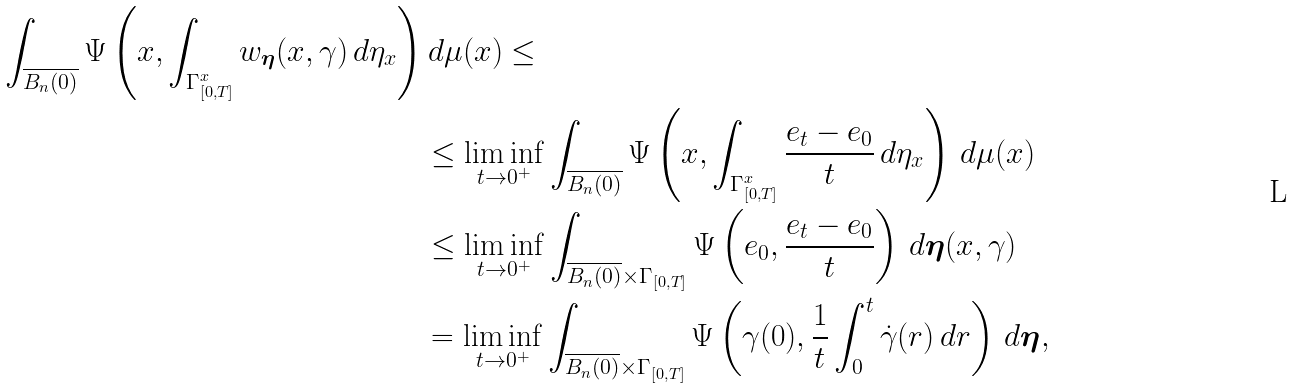Convert formula to latex. <formula><loc_0><loc_0><loc_500><loc_500>\int _ { \overline { B _ { n } ( 0 ) } } \Psi \left ( x , \int _ { \Gamma ^ { x } _ { [ 0 , T ] } } w _ { \boldsymbol \eta } ( x , \gamma ) \, d \eta _ { x } \right ) & \, d \mu ( x ) \leq \\ & \leq \liminf _ { t \to 0 ^ { + } } \int _ { \overline { B _ { n } ( 0 ) } } \Psi \left ( x , \int _ { \Gamma ^ { x } _ { [ 0 , T ] } } \frac { e _ { t } - e _ { 0 } } { t } \, d \eta _ { x } \right ) \, d \mu ( x ) \\ & \leq \liminf _ { t \to 0 ^ { + } } \int _ { \overline { B _ { n } ( 0 ) } \times \Gamma _ { [ 0 , T ] } } \Psi \left ( e _ { 0 } , \frac { e _ { t } - e _ { 0 } } { t } \right ) \, d \boldsymbol \eta ( x , \gamma ) \\ & = \liminf _ { t \to 0 ^ { + } } \int _ { \overline { B _ { n } ( 0 ) } \times \Gamma _ { [ 0 , T ] } } \Psi \left ( \gamma ( 0 ) , \frac { 1 } { t } \int _ { 0 } ^ { t } \dot { \gamma } ( r ) \, d r \right ) \, d \boldsymbol \eta ,</formula> 